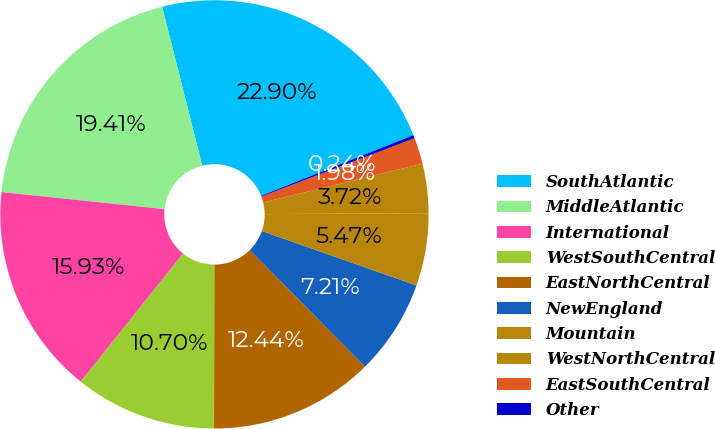Convert chart to OTSL. <chart><loc_0><loc_0><loc_500><loc_500><pie_chart><fcel>SouthAtlantic<fcel>MiddleAtlantic<fcel>International<fcel>WestSouthCentral<fcel>EastNorthCentral<fcel>NewEngland<fcel>Mountain<fcel>WestNorthCentral<fcel>EastSouthCentral<fcel>Other<nl><fcel>22.9%<fcel>19.41%<fcel>15.93%<fcel>10.7%<fcel>12.44%<fcel>7.21%<fcel>5.47%<fcel>3.72%<fcel>1.98%<fcel>0.24%<nl></chart> 